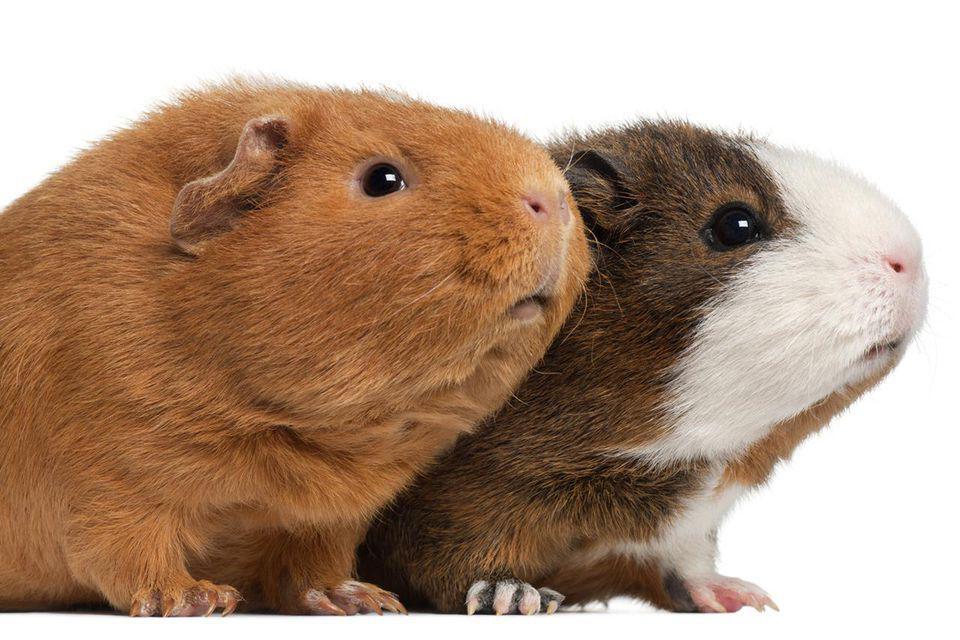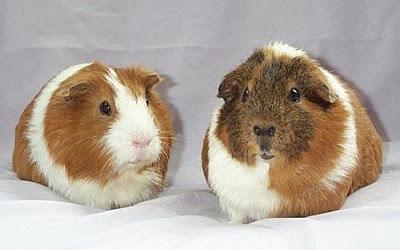The first image is the image on the left, the second image is the image on the right. Examine the images to the left and right. Is the description "Each image contains one pair of side-by-side guinea pigs and includes at least one guinea pig that is not solid colored." accurate? Answer yes or no. Yes. The first image is the image on the left, the second image is the image on the right. Evaluate the accuracy of this statement regarding the images: "Both images have two guinea pigs in them.". Is it true? Answer yes or no. Yes. 